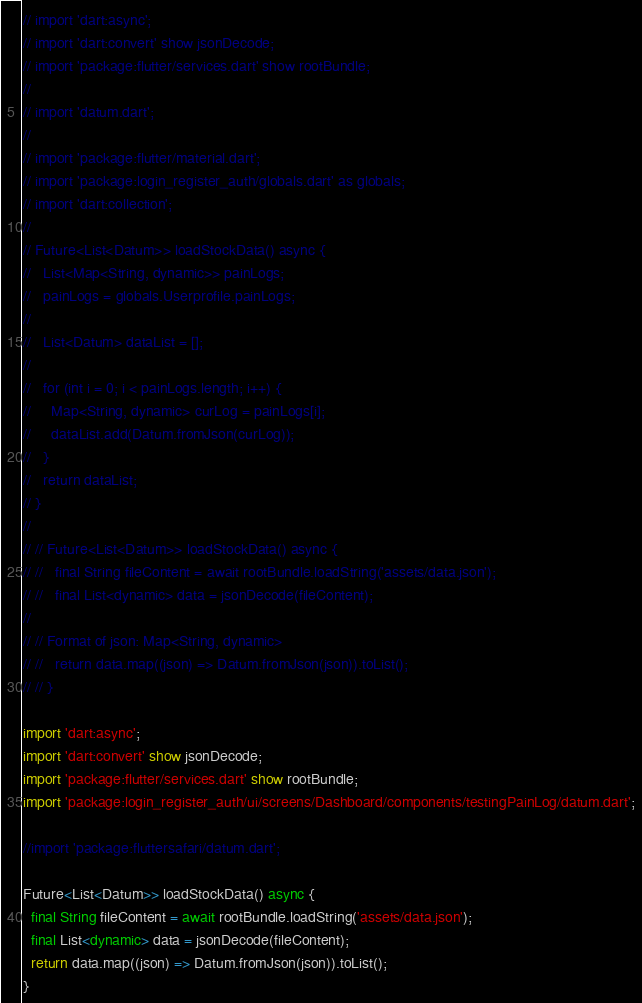Convert code to text. <code><loc_0><loc_0><loc_500><loc_500><_Dart_>// import 'dart:async';
// import 'dart:convert' show jsonDecode;
// import 'package:flutter/services.dart' show rootBundle;
//
// import 'datum.dart';
//
// import 'package:flutter/material.dart';
// import 'package:login_register_auth/globals.dart' as globals;
// import 'dart:collection';
//
// Future<List<Datum>> loadStockData() async {
//   List<Map<String, dynamic>> painLogs;
//   painLogs = globals.Userprofile.painLogs;
//
//   List<Datum> dataList = [];
//
//   for (int i = 0; i < painLogs.length; i++) {
//     Map<String, dynamic> curLog = painLogs[i];
//     dataList.add(Datum.fromJson(curLog));
//   }
//   return dataList;
// }
//
// // Future<List<Datum>> loadStockData() async {
// //   final String fileContent = await rootBundle.loadString('assets/data.json');
// //   final List<dynamic> data = jsonDecode(fileContent);
//
// // Format of json: Map<String, dynamic>
// //   return data.map((json) => Datum.fromJson(json)).toList();
// // }

import 'dart:async';
import 'dart:convert' show jsonDecode;
import 'package:flutter/services.dart' show rootBundle;
import 'package:login_register_auth/ui/screens/Dashboard/components/testingPainLog/datum.dart';

//import 'package:fluttersafari/datum.dart';

Future<List<Datum>> loadStockData() async {
  final String fileContent = await rootBundle.loadString('assets/data.json');
  final List<dynamic> data = jsonDecode(fileContent);
  return data.map((json) => Datum.fromJson(json)).toList();
}
</code> 